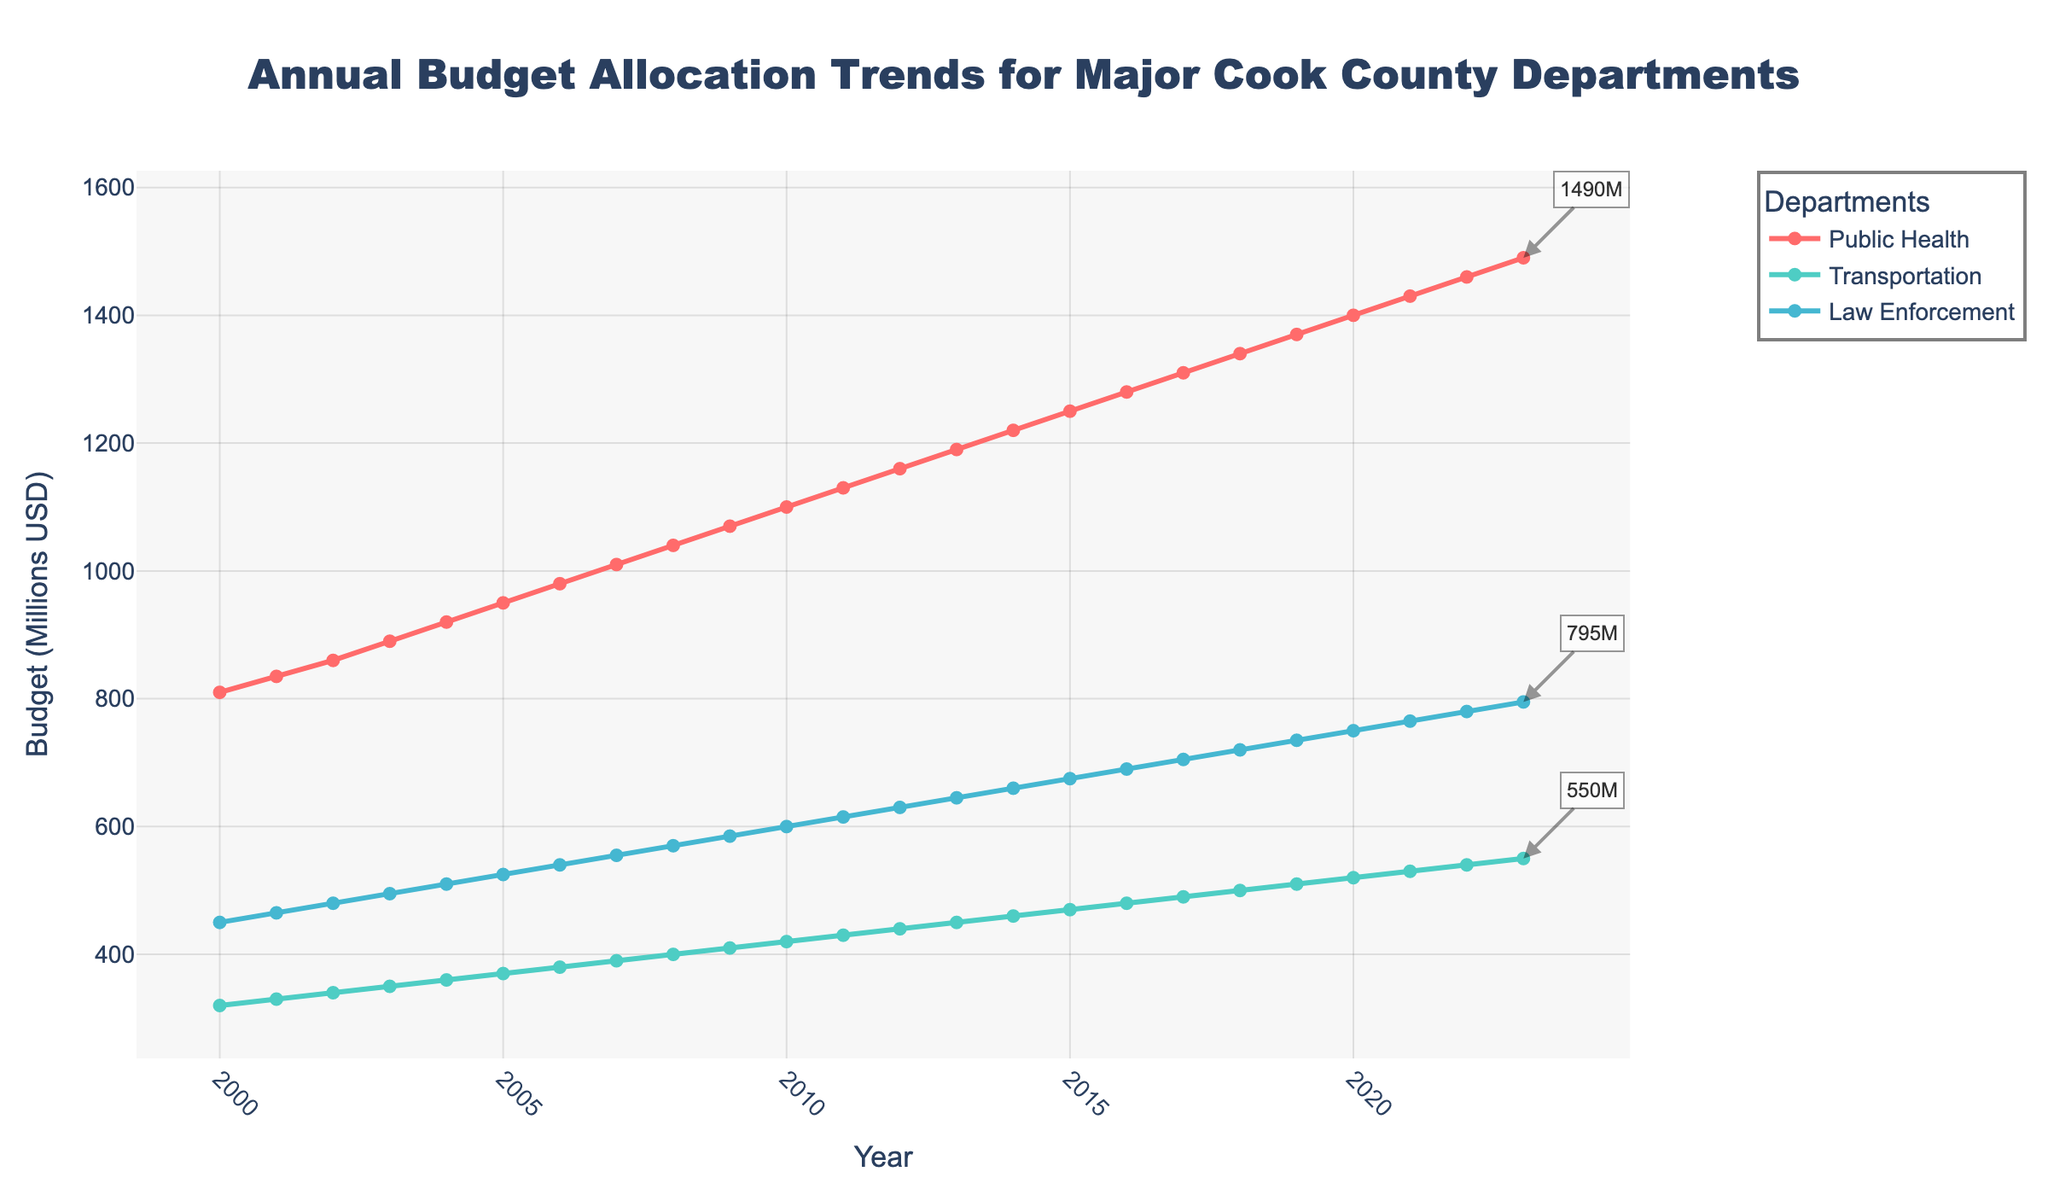What's the difference in budget allocation between Public Health and Transportation in 2005? To find the difference, subtract the Transportation budget from the Public Health budget in 2005: \$950,000,000 - \$370,000,000 = \$580,000,000.
Answer: \$580,000,000 Which department had the highest budget allocation in 2010? In 2010, compare the budgets for Public Health, Transportation, and Law Enforcement. Public Health had \$1,100,000,000, Transportation had \$420,000,000, and Law Enforcement had \$600,000,000. Public Health had the highest budget allocation.
Answer: Public Health What is the average annual budget allocation for Law Enforcement from 2000 to 2023? First, sum the annual budgets for Law Enforcement from 2000 to 2023, then divide by the number of years (24). The calculation is: (\$450,000,000 + \$465,000,000 + \$480,000,000 + ... + \$795,000,000) / 24. The total is \$15,015,000,000, so the average is \$15,015,000,000 / 24 = \$625,625,000.
Answer: \$625,625,000 By how much has the Public Health budget increased from 2000 to 2023? Subtract the Public Health budget in 2000 from the budget in 2023: \$1,490,000,000 - \$810,000,000 = \$680,000,000.
Answer: \$680,000,000 Which department had the smallest relative increase in budget allocation from 2000 to 2023? Calculate the relative increase for each department: 
1. Public Health: (\$1,490,000,000 - \$810,000,000) / \$810,000,000 = 0.8395 or 83.95%.
2. Transportation: (\$550,000,000 - \$320,000,000) / \$320,000,000 = 0.71875 or 71.88%.
3. Law Enforcement: (\$795,000,000 - \$450,000,000) / \$450,000,000 = 0.7667 or 76.67%.
Transportation had the smallest relative increase.
Answer: Transportation What was the percentage increase in the Law Enforcement budget from 2010 to 2020? Calculate the percentage increase: \[\left(\frac{\$750,000,000 - \$600,000,000}{\$600,000,000}\right) \times 100 = 25\%\].
Answer: 25% Compare the budget allocation trends for Public Health and Law Enforcement. Which department's budget has grown more consistently? Examine the plotted lines for Public Health and Law Enforcement. The Public Health budget shows a more consistent and steady increase over time compared to the Law Enforcement budget, which has occasional sharp increases.
Answer: Public Health In which year did the Transportation budget first exceed \$500 million? Locate the year when the Transportation budget surpassed \$500,000,000. This occurred in 2018.
Answer: 2018 What is the combined budget for all three departments in 2023? Sum the budgets for Public Health, Transportation, and Law Enforcement in 2023: \$1,490,000,000 + \$550,000,000 + \$795,000,000 = \$2,835,000,000.
Answer: \$2,835,000,000 Which department has the second highest budget allocation in 2023? Compare the 2023 budgets for the three departments. Public Health has the highest at \$1,490,000,000, Law Enforcement follows at \$795,000,000, and Transportation is third at \$550,000,000. Law Enforcement has the second highest budget.
Answer: Law Enforcement 